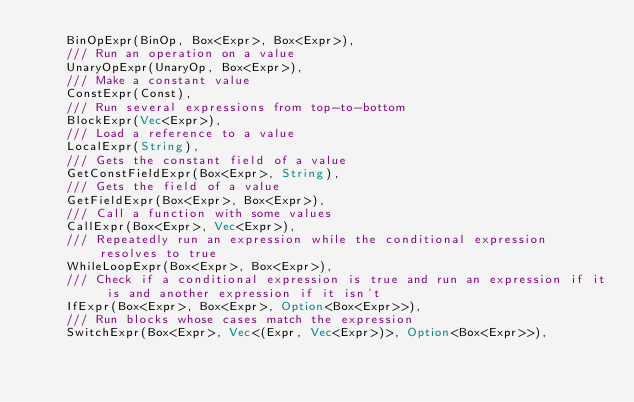<code> <loc_0><loc_0><loc_500><loc_500><_Rust_>    BinOpExpr(BinOp, Box<Expr>, Box<Expr>),
    /// Run an operation on a value
    UnaryOpExpr(UnaryOp, Box<Expr>),
    /// Make a constant value
    ConstExpr(Const),
    /// Run several expressions from top-to-bottom
    BlockExpr(Vec<Expr>),
    /// Load a reference to a value
    LocalExpr(String),
    /// Gets the constant field of a value
    GetConstFieldExpr(Box<Expr>, String),
    /// Gets the field of a value
    GetFieldExpr(Box<Expr>, Box<Expr>),
    /// Call a function with some values
    CallExpr(Box<Expr>, Vec<Expr>),
    /// Repeatedly run an expression while the conditional expression resolves to true
    WhileLoopExpr(Box<Expr>, Box<Expr>),
    /// Check if a conditional expression is true and run an expression if it is and another expression if it isn't
    IfExpr(Box<Expr>, Box<Expr>, Option<Box<Expr>>),
    /// Run blocks whose cases match the expression
    SwitchExpr(Box<Expr>, Vec<(Expr, Vec<Expr>)>, Option<Box<Expr>>),</code> 